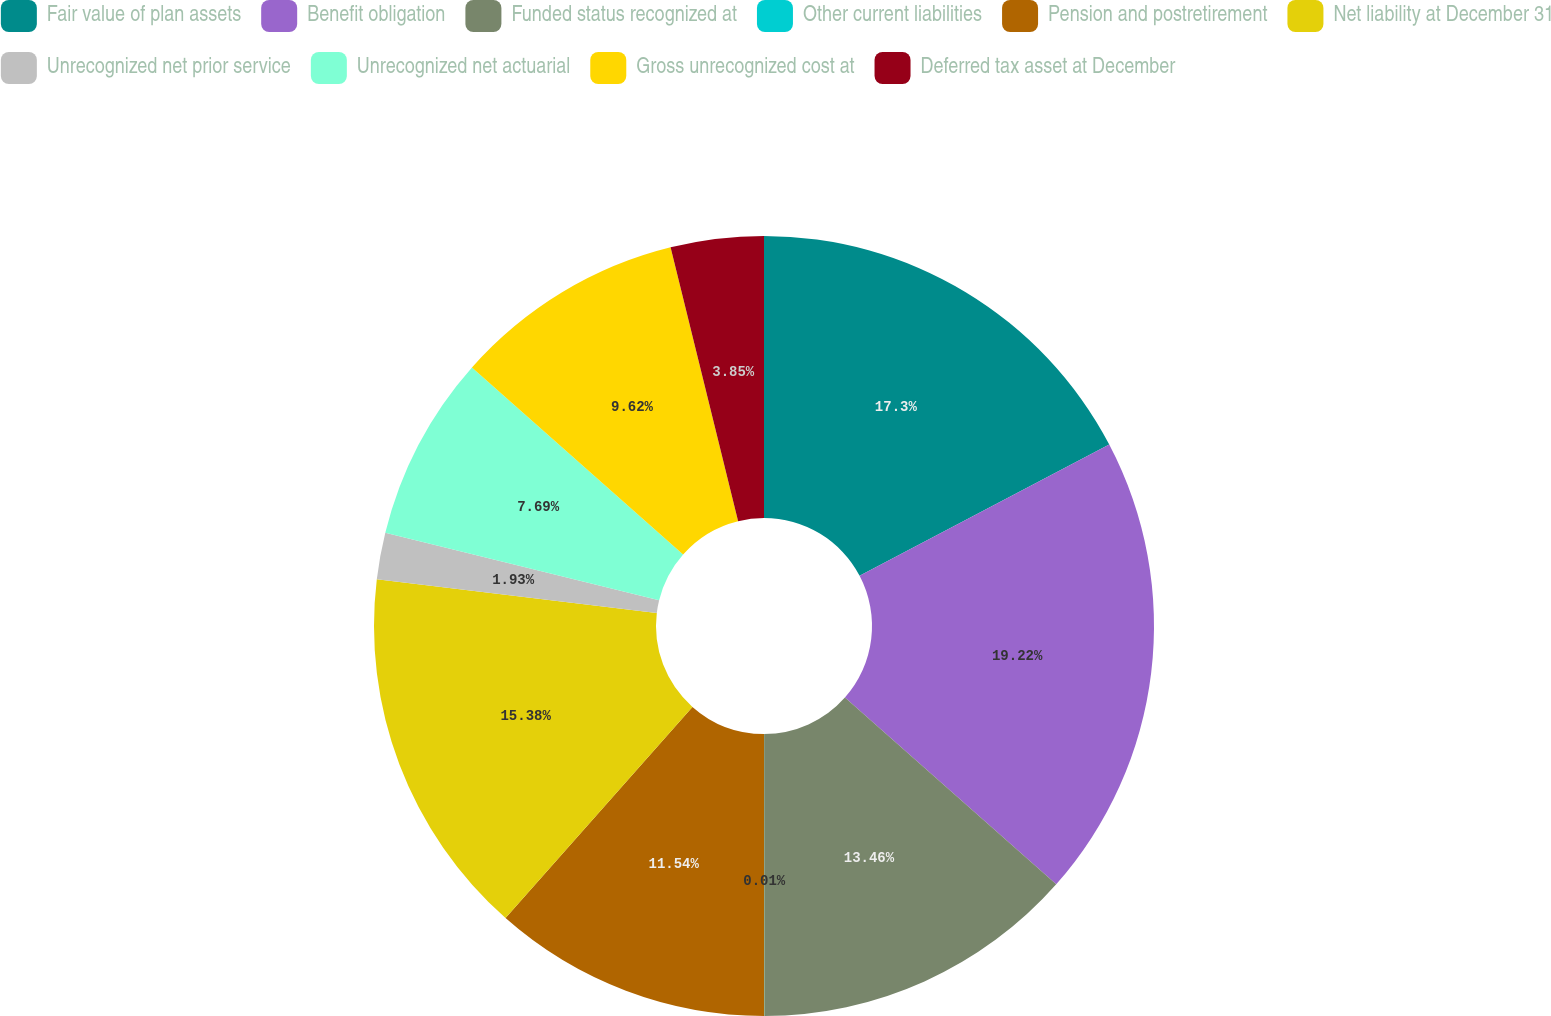Convert chart to OTSL. <chart><loc_0><loc_0><loc_500><loc_500><pie_chart><fcel>Fair value of plan assets<fcel>Benefit obligation<fcel>Funded status recognized at<fcel>Other current liabilities<fcel>Pension and postretirement<fcel>Net liability at December 31<fcel>Unrecognized net prior service<fcel>Unrecognized net actuarial<fcel>Gross unrecognized cost at<fcel>Deferred tax asset at December<nl><fcel>17.3%<fcel>19.22%<fcel>13.46%<fcel>0.01%<fcel>11.54%<fcel>15.38%<fcel>1.93%<fcel>7.69%<fcel>9.62%<fcel>3.85%<nl></chart> 